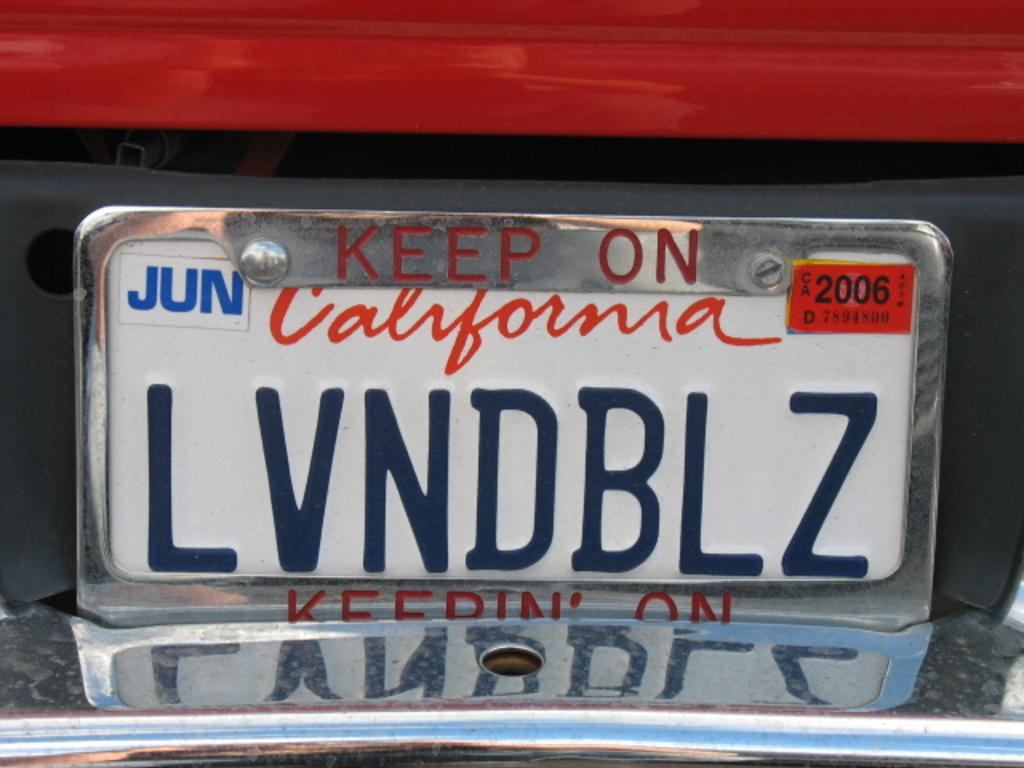Provide a one-sentence caption for the provided image. a red car with the license plate lvndblz. 